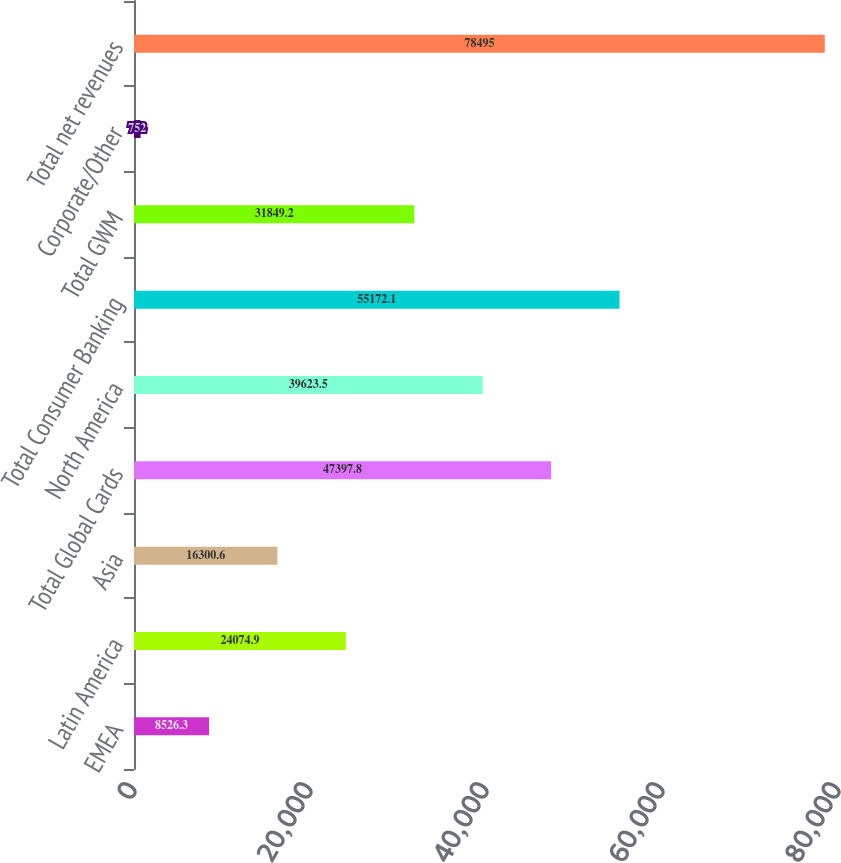Convert chart to OTSL. <chart><loc_0><loc_0><loc_500><loc_500><bar_chart><fcel>EMEA<fcel>Latin America<fcel>Asia<fcel>Total Global Cards<fcel>North America<fcel>Total Consumer Banking<fcel>Total GWM<fcel>Corporate/Other<fcel>Total net revenues<nl><fcel>8526.3<fcel>24074.9<fcel>16300.6<fcel>47397.8<fcel>39623.5<fcel>55172.1<fcel>31849.2<fcel>752<fcel>78495<nl></chart> 